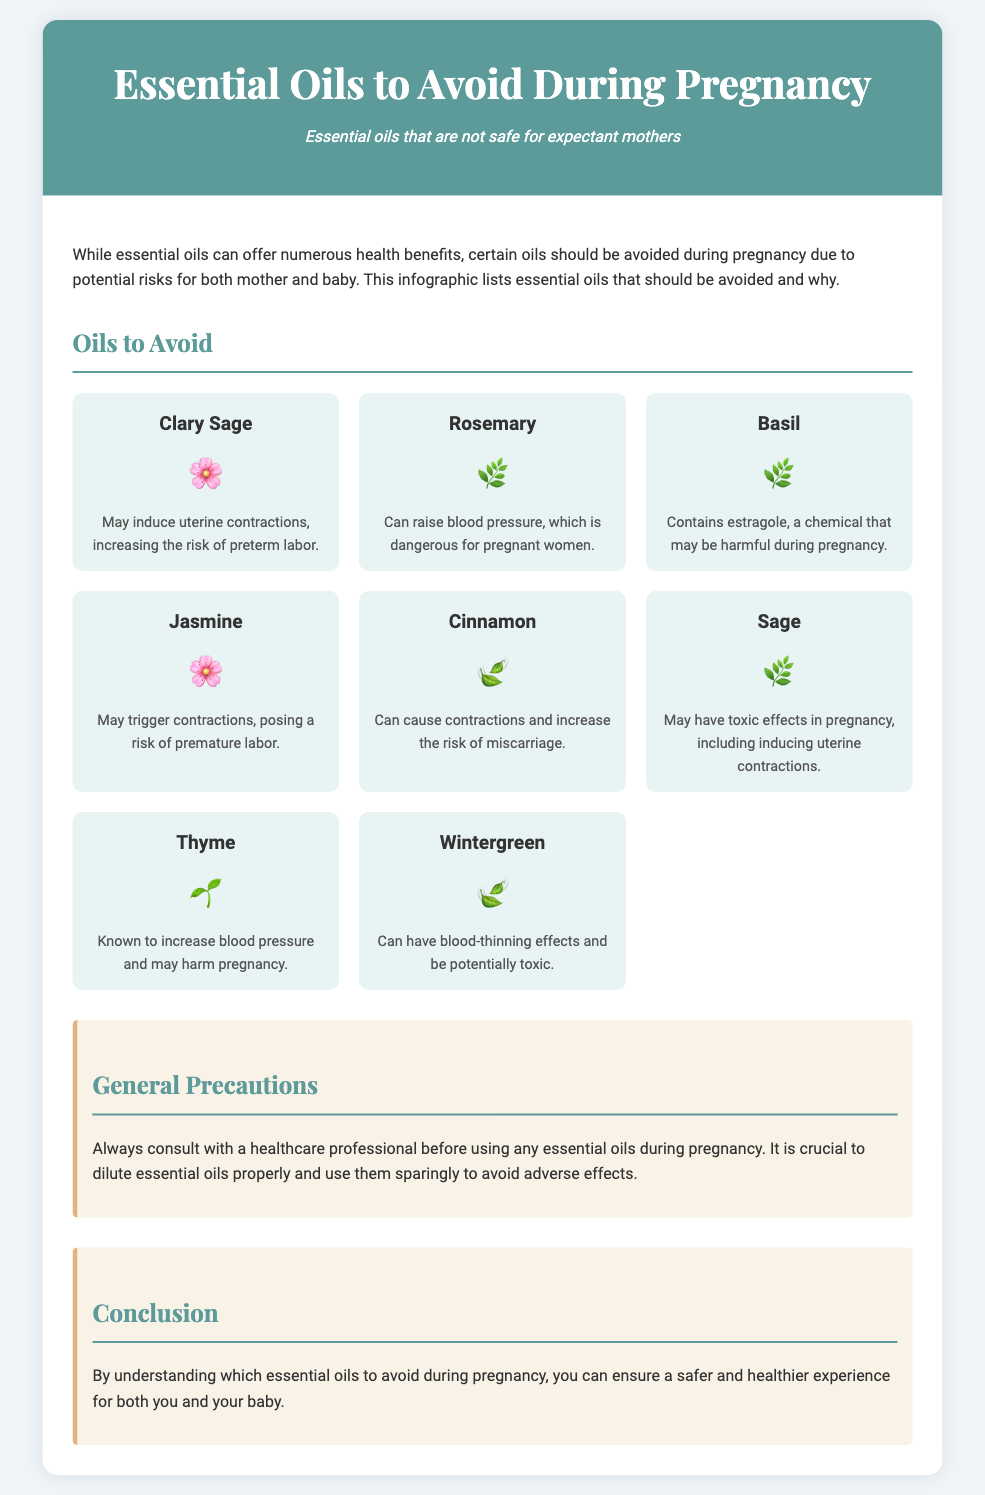What essential oil may induce uterine contractions? The document lists Clary Sage as an essential oil that may induce uterine contractions, increasing the risk of preterm labor.
Answer: Clary Sage Which essential oil should be avoided due to high blood pressure risk? The document states that Rosemary can raise blood pressure, which is dangerous for pregnant women.
Answer: Rosemary What is one potential risk associated with Cinnamon oil? The document indicates that Cinnamon can cause contractions and increase the risk of miscarriage.
Answer: Miscarriage How many essential oils are listed as to be avoided during pregnancy? The document features a total of eight essential oils that should be avoided during pregnancy.
Answer: Eight What essential oil contains estragole? The document mentions that Basil contains estragole, a chemical that may be harmful during pregnancy.
Answer: Basil What general precaution does the document suggest regarding essential oils during pregnancy? The document advises to always consult with a healthcare professional before using any essential oils during pregnancy.
Answer: Consult a healthcare professional Which essential oil is known for potentially blood-thinning effects? The document lists Wintergreen as having blood-thinning effects and being potentially toxic.
Answer: Wintergreen What should be done before using any essential oils during pregnancy? The document emphasizes the importance of diluting essential oils properly and using them sparingly to avoid adverse effects.
Answer: Dilute and use sparingly 